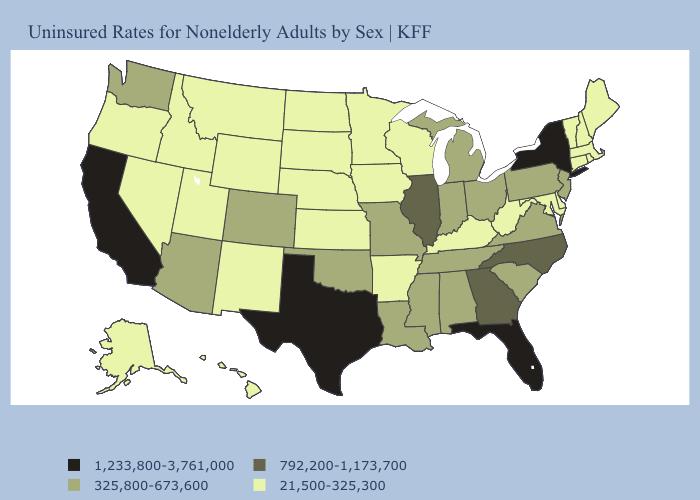Among the states that border Tennessee , does Missouri have the highest value?
Be succinct. No. Does Texas have the highest value in the USA?
Quick response, please. Yes. Name the states that have a value in the range 325,800-673,600?
Write a very short answer. Alabama, Arizona, Colorado, Indiana, Louisiana, Michigan, Mississippi, Missouri, New Jersey, Ohio, Oklahoma, Pennsylvania, South Carolina, Tennessee, Virginia, Washington. Does the first symbol in the legend represent the smallest category?
Write a very short answer. No. Which states have the highest value in the USA?
Write a very short answer. California, Florida, New York, Texas. What is the value of Kentucky?
Be succinct. 21,500-325,300. What is the value of Maine?
Short answer required. 21,500-325,300. What is the value of Montana?
Concise answer only. 21,500-325,300. Does New Jersey have the lowest value in the USA?
Answer briefly. No. Does the map have missing data?
Be succinct. No. What is the value of New Jersey?
Write a very short answer. 325,800-673,600. Among the states that border Vermont , which have the highest value?
Keep it brief. New York. What is the value of Washington?
Be succinct. 325,800-673,600. Is the legend a continuous bar?
Quick response, please. No. What is the highest value in the USA?
Give a very brief answer. 1,233,800-3,761,000. 